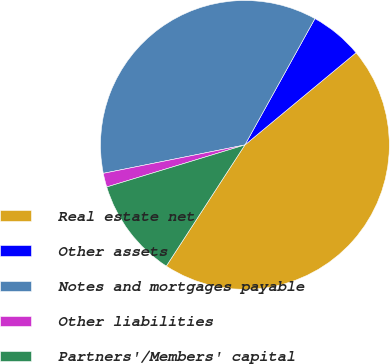Convert chart to OTSL. <chart><loc_0><loc_0><loc_500><loc_500><pie_chart><fcel>Real estate net<fcel>Other assets<fcel>Notes and mortgages payable<fcel>Other liabilities<fcel>Partners'/Members' capital<nl><fcel>45.19%<fcel>5.92%<fcel>36.21%<fcel>1.55%<fcel>11.14%<nl></chart> 